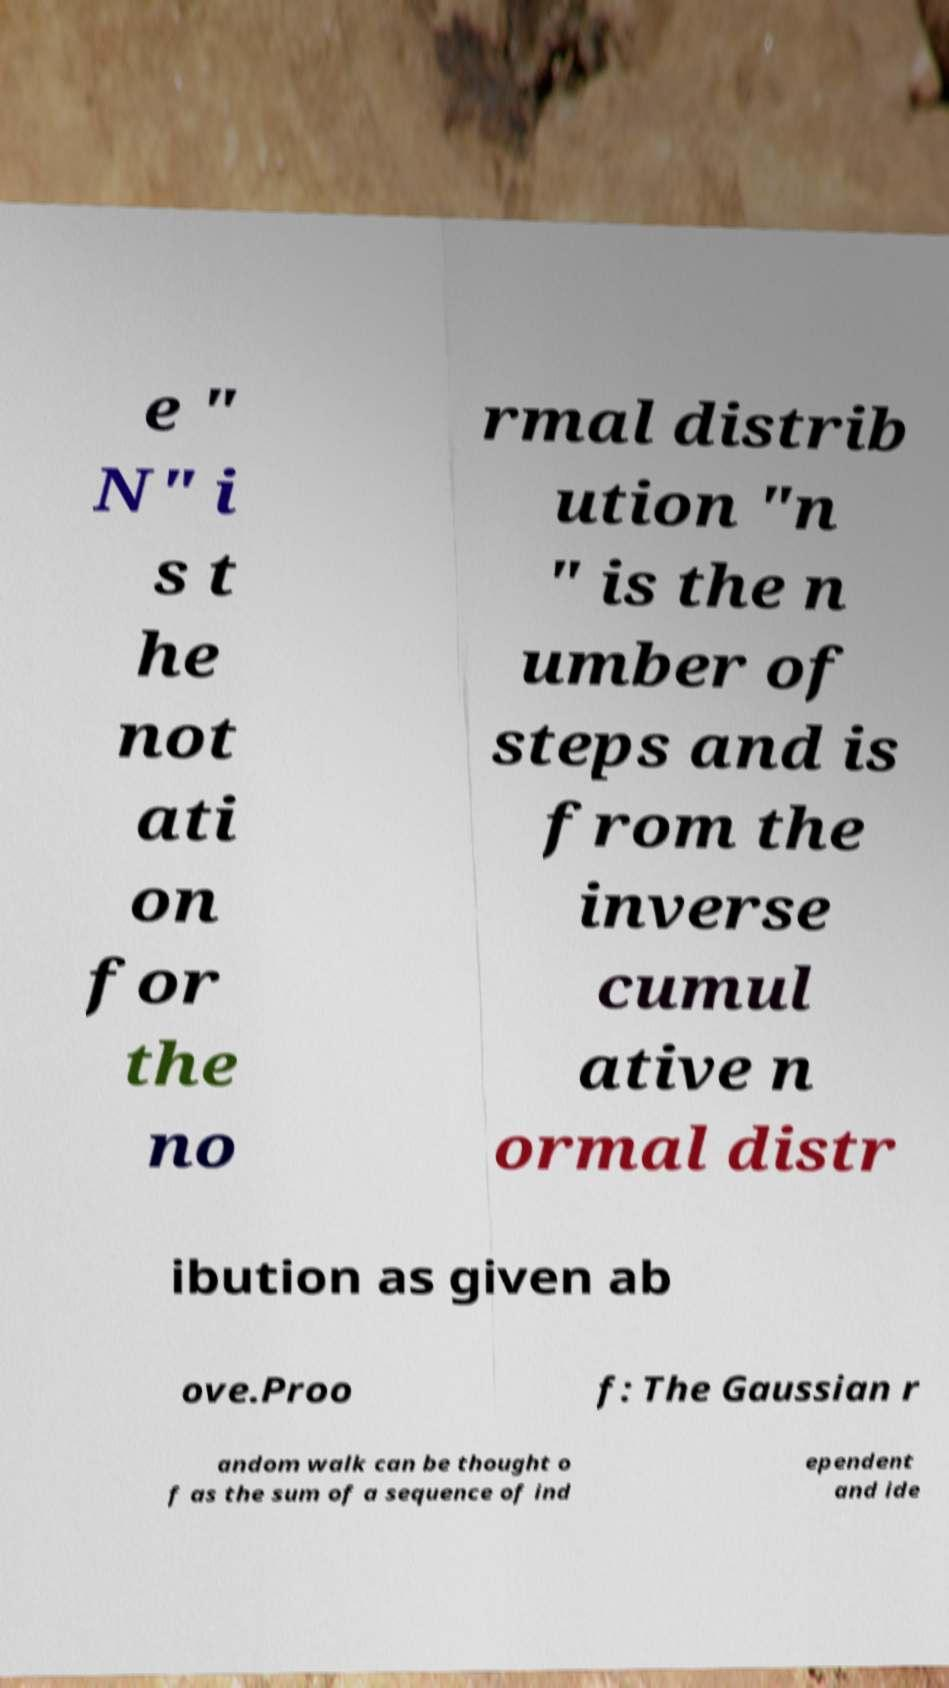What messages or text are displayed in this image? I need them in a readable, typed format. e " N" i s t he not ati on for the no rmal distrib ution "n " is the n umber of steps and is from the inverse cumul ative n ormal distr ibution as given ab ove.Proo f: The Gaussian r andom walk can be thought o f as the sum of a sequence of ind ependent and ide 